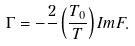Convert formula to latex. <formula><loc_0><loc_0><loc_500><loc_500>\Gamma = - \frac { 2 } { } \left ( \frac { T _ { 0 } } { T } \right ) I m F .</formula> 